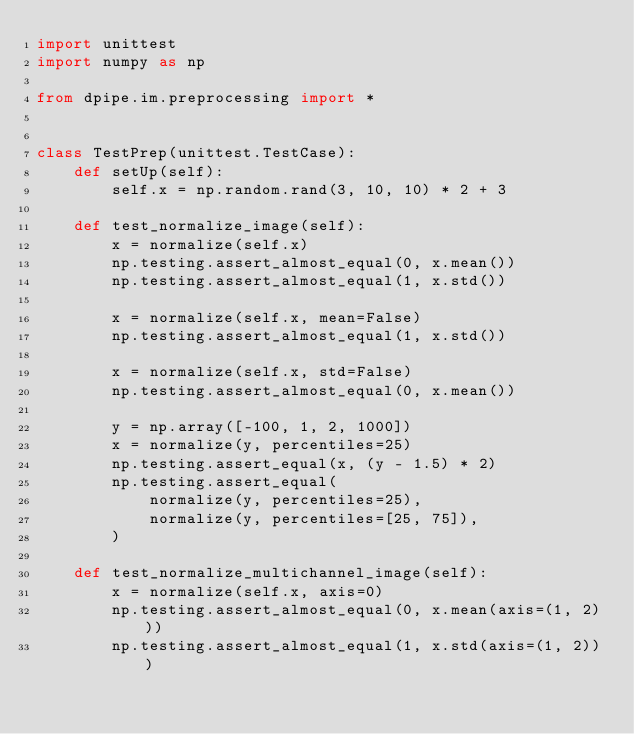Convert code to text. <code><loc_0><loc_0><loc_500><loc_500><_Python_>import unittest
import numpy as np

from dpipe.im.preprocessing import *


class TestPrep(unittest.TestCase):
    def setUp(self):
        self.x = np.random.rand(3, 10, 10) * 2 + 3

    def test_normalize_image(self):
        x = normalize(self.x)
        np.testing.assert_almost_equal(0, x.mean())
        np.testing.assert_almost_equal(1, x.std())

        x = normalize(self.x, mean=False)
        np.testing.assert_almost_equal(1, x.std())

        x = normalize(self.x, std=False)
        np.testing.assert_almost_equal(0, x.mean())

        y = np.array([-100, 1, 2, 1000])
        x = normalize(y, percentiles=25)
        np.testing.assert_equal(x, (y - 1.5) * 2)
        np.testing.assert_equal(
            normalize(y, percentiles=25),
            normalize(y, percentiles=[25, 75]),
        )

    def test_normalize_multichannel_image(self):
        x = normalize(self.x, axis=0)
        np.testing.assert_almost_equal(0, x.mean(axis=(1, 2)))
        np.testing.assert_almost_equal(1, x.std(axis=(1, 2)))
</code> 